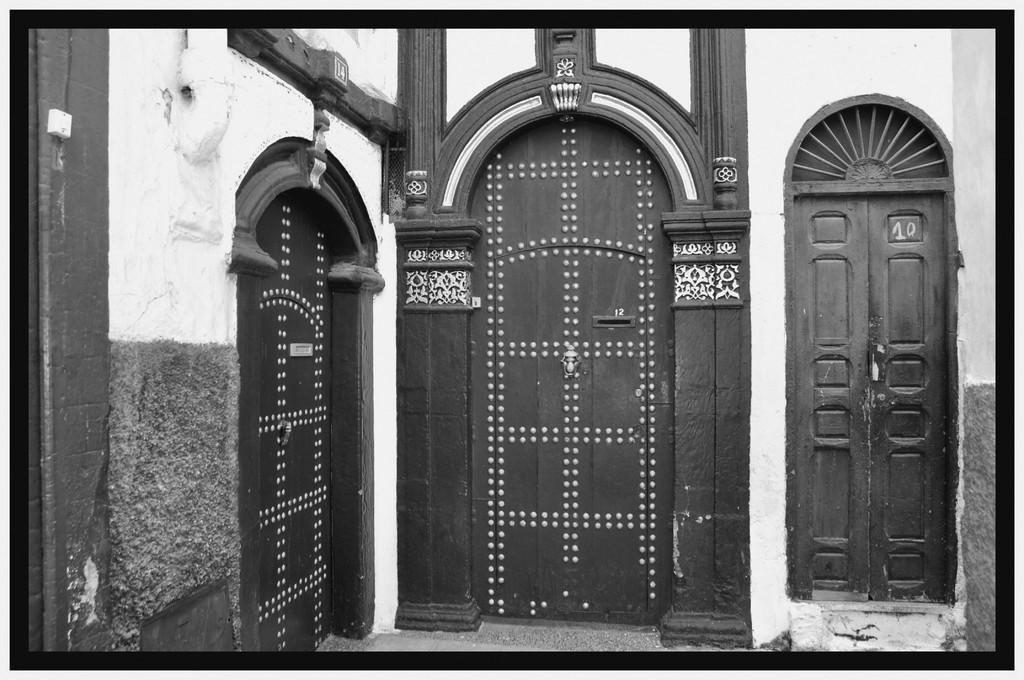Describe this image in one or two sentences. In this picture we can see doors, wall, pipe and a switchboard. 